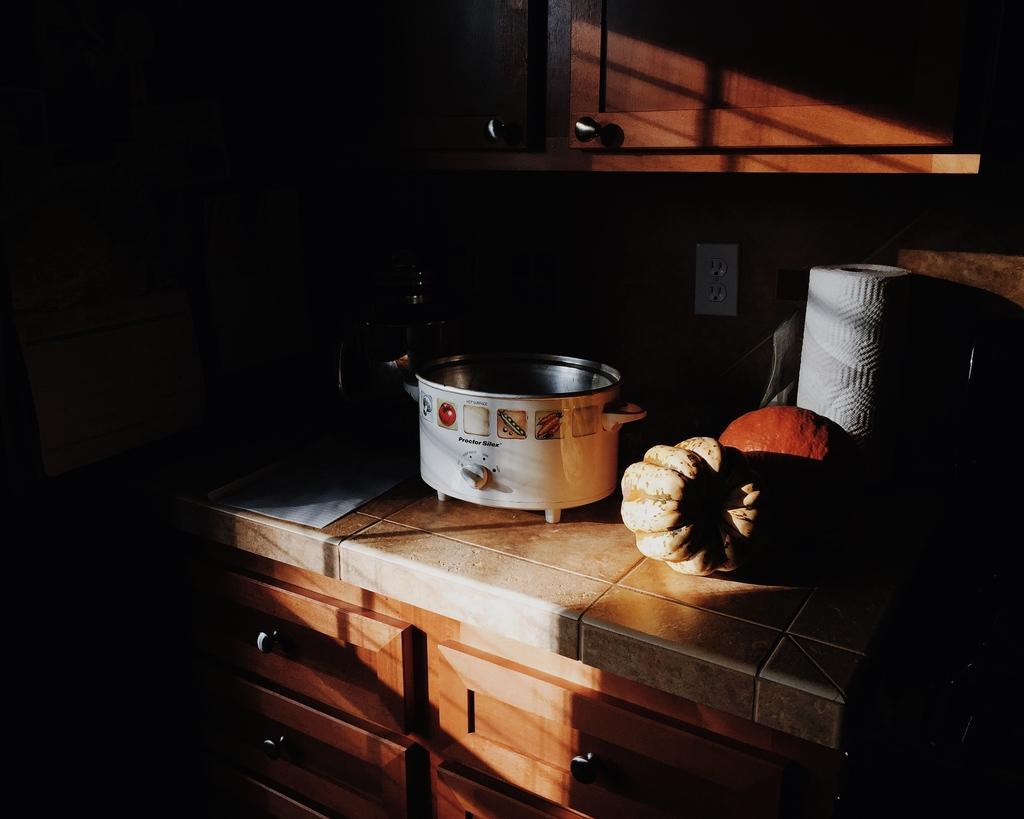How would you summarize this image in a sentence or two? These are cupboards. On this platform we can see tissue paper roll, electric cooker and things. Socket is on the wall. 